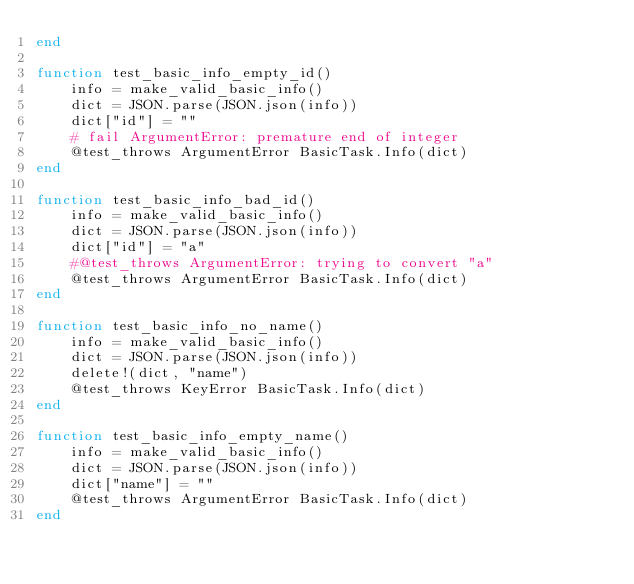Convert code to text. <code><loc_0><loc_0><loc_500><loc_500><_Julia_>end

function test_basic_info_empty_id()
    info = make_valid_basic_info()
    dict = JSON.parse(JSON.json(info))
    dict["id"] = ""
    # fail ArgumentError: premature end of integer
    @test_throws ArgumentError BasicTask.Info(dict)
end

function test_basic_info_bad_id()
    info = make_valid_basic_info()
    dict = JSON.parse(JSON.json(info))
    dict["id"] = "a"
    #@test_throws ArgumentError: trying to convert "a"
    @test_throws ArgumentError BasicTask.Info(dict)
end

function test_basic_info_no_name()
    info = make_valid_basic_info()
    dict = JSON.parse(JSON.json(info))
    delete!(dict, "name")
    @test_throws KeyError BasicTask.Info(dict)
end

function test_basic_info_empty_name()
    info = make_valid_basic_info()
    dict = JSON.parse(JSON.json(info))
    dict["name"] = ""
    @test_throws ArgumentError BasicTask.Info(dict)
end
</code> 